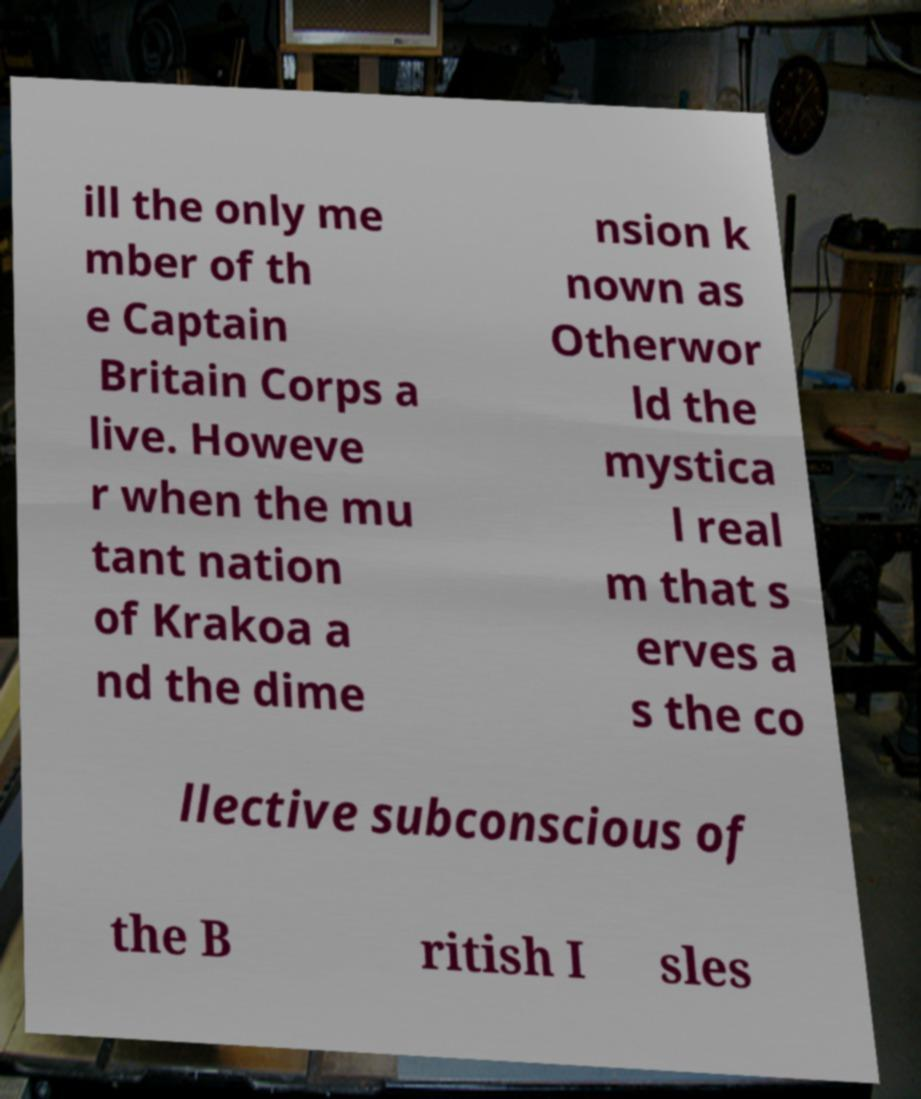Could you assist in decoding the text presented in this image and type it out clearly? ill the only me mber of th e Captain Britain Corps a live. Howeve r when the mu tant nation of Krakoa a nd the dime nsion k nown as Otherwor ld the mystica l real m that s erves a s the co llective subconscious of the B ritish I sles 